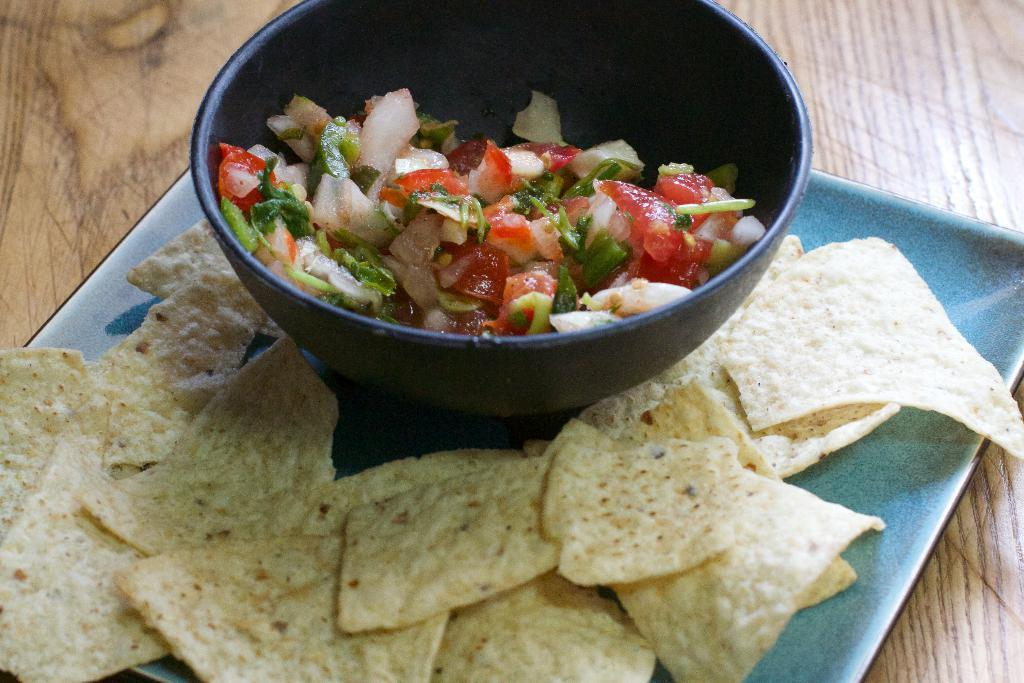What type of food items can be seen in the image? There are food items in a bowl and on a plate. Where are the food items located? The objects containing the food items are on a wooden surface. How many different containers are there for the food items? There is a bowl and a plate, so there are two different containers for the food items. What song is being played by the food items on the wooden surface? There is no song being played by the food items in the image; they are simply food items in containers on a wooden surface. 